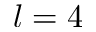Convert formula to latex. <formula><loc_0><loc_0><loc_500><loc_500>l = 4</formula> 